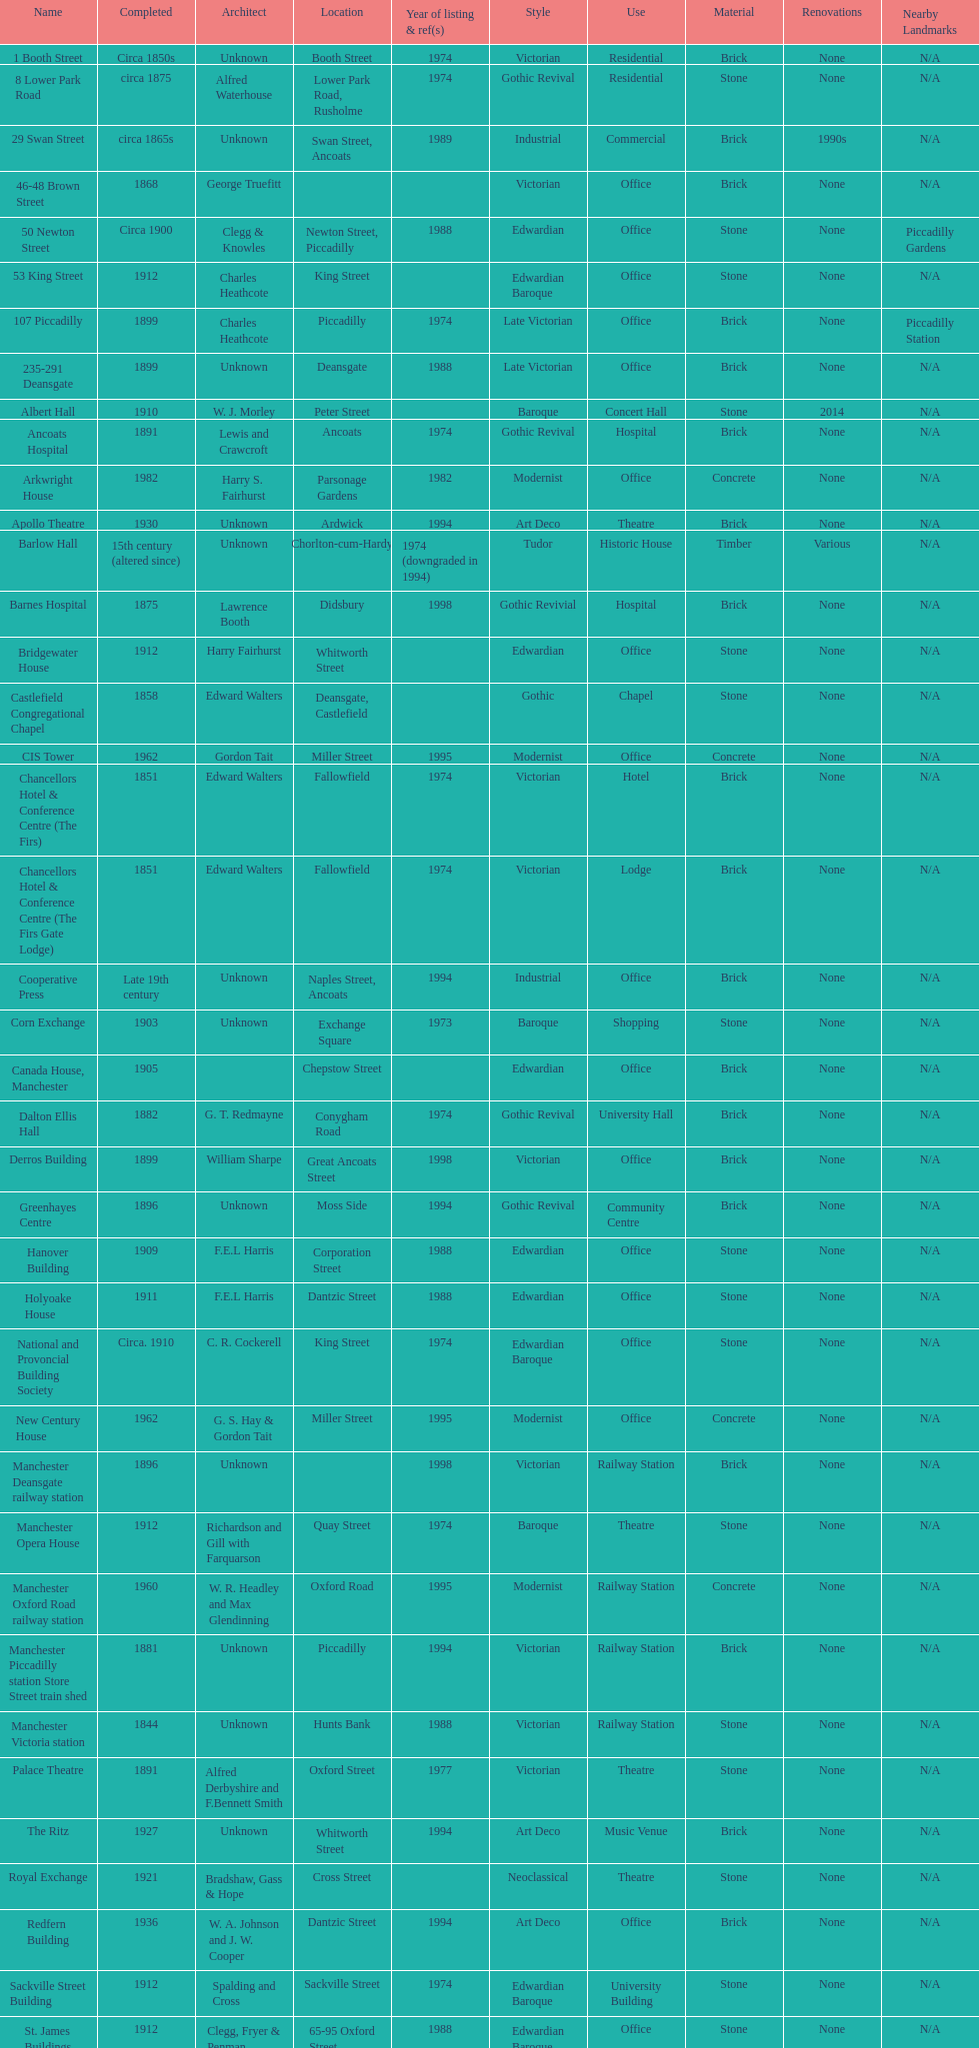How many buildings do not have an image listed? 11. 